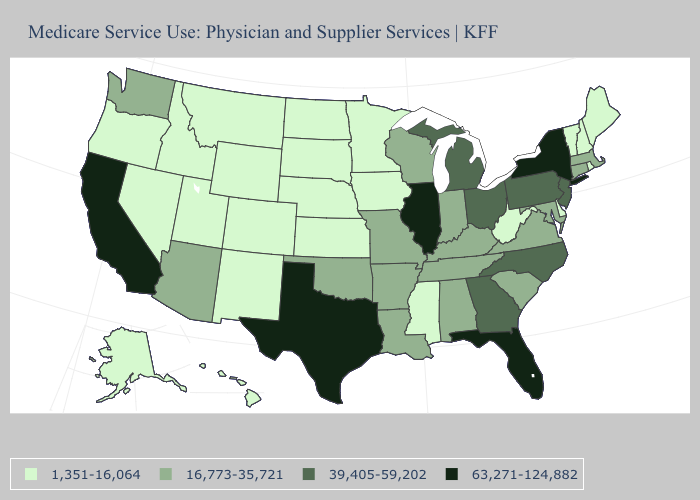What is the lowest value in states that border New Jersey?
Write a very short answer. 1,351-16,064. Does Virginia have the same value as Vermont?
Concise answer only. No. Does Washington have a higher value than Maine?
Concise answer only. Yes. Name the states that have a value in the range 63,271-124,882?
Be succinct. California, Florida, Illinois, New York, Texas. Name the states that have a value in the range 63,271-124,882?
Answer briefly. California, Florida, Illinois, New York, Texas. Name the states that have a value in the range 63,271-124,882?
Answer briefly. California, Florida, Illinois, New York, Texas. Name the states that have a value in the range 16,773-35,721?
Keep it brief. Alabama, Arizona, Arkansas, Connecticut, Indiana, Kentucky, Louisiana, Maryland, Massachusetts, Missouri, Oklahoma, South Carolina, Tennessee, Virginia, Washington, Wisconsin. Name the states that have a value in the range 16,773-35,721?
Write a very short answer. Alabama, Arizona, Arkansas, Connecticut, Indiana, Kentucky, Louisiana, Maryland, Massachusetts, Missouri, Oklahoma, South Carolina, Tennessee, Virginia, Washington, Wisconsin. Which states have the lowest value in the USA?
Keep it brief. Alaska, Colorado, Delaware, Hawaii, Idaho, Iowa, Kansas, Maine, Minnesota, Mississippi, Montana, Nebraska, Nevada, New Hampshire, New Mexico, North Dakota, Oregon, Rhode Island, South Dakota, Utah, Vermont, West Virginia, Wyoming. Does Ohio have a higher value than South Carolina?
Short answer required. Yes. Does Massachusetts have a lower value than New York?
Keep it brief. Yes. Is the legend a continuous bar?
Write a very short answer. No. Does New York have the highest value in the Northeast?
Give a very brief answer. Yes. 